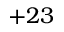Convert formula to latex. <formula><loc_0><loc_0><loc_500><loc_500>+ 2 3</formula> 